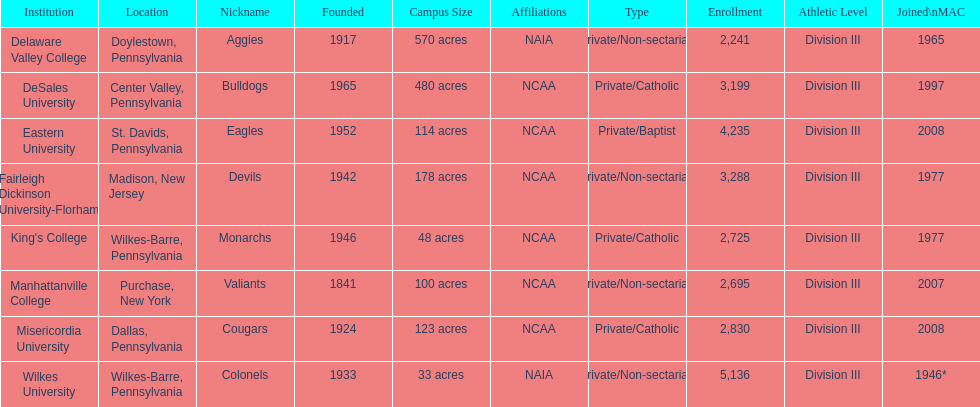Name each institution with enrollment numbers above 4,000? Eastern University, Wilkes University. 